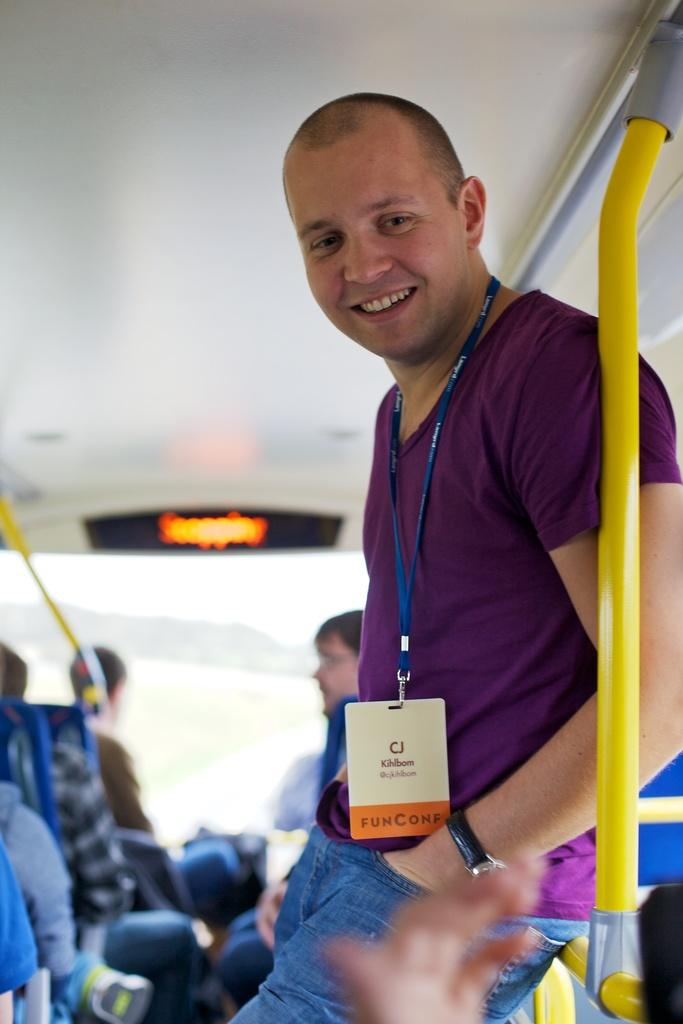What is the man in the image doing? The man in the image is holding a rod. What is the man wearing that might identify him? The man is wearing an ID card. How is the man's expression in the image? The man is smiling. What else can be seen in the image besides the man? There are people inside a vehicle. What type of jewel is the man wearing on his head in the image? There is no jewel visible on the man's head in the image. What type of plate is the man holding in the image? The man is not holding a plate in the image; he is holding a rod. 